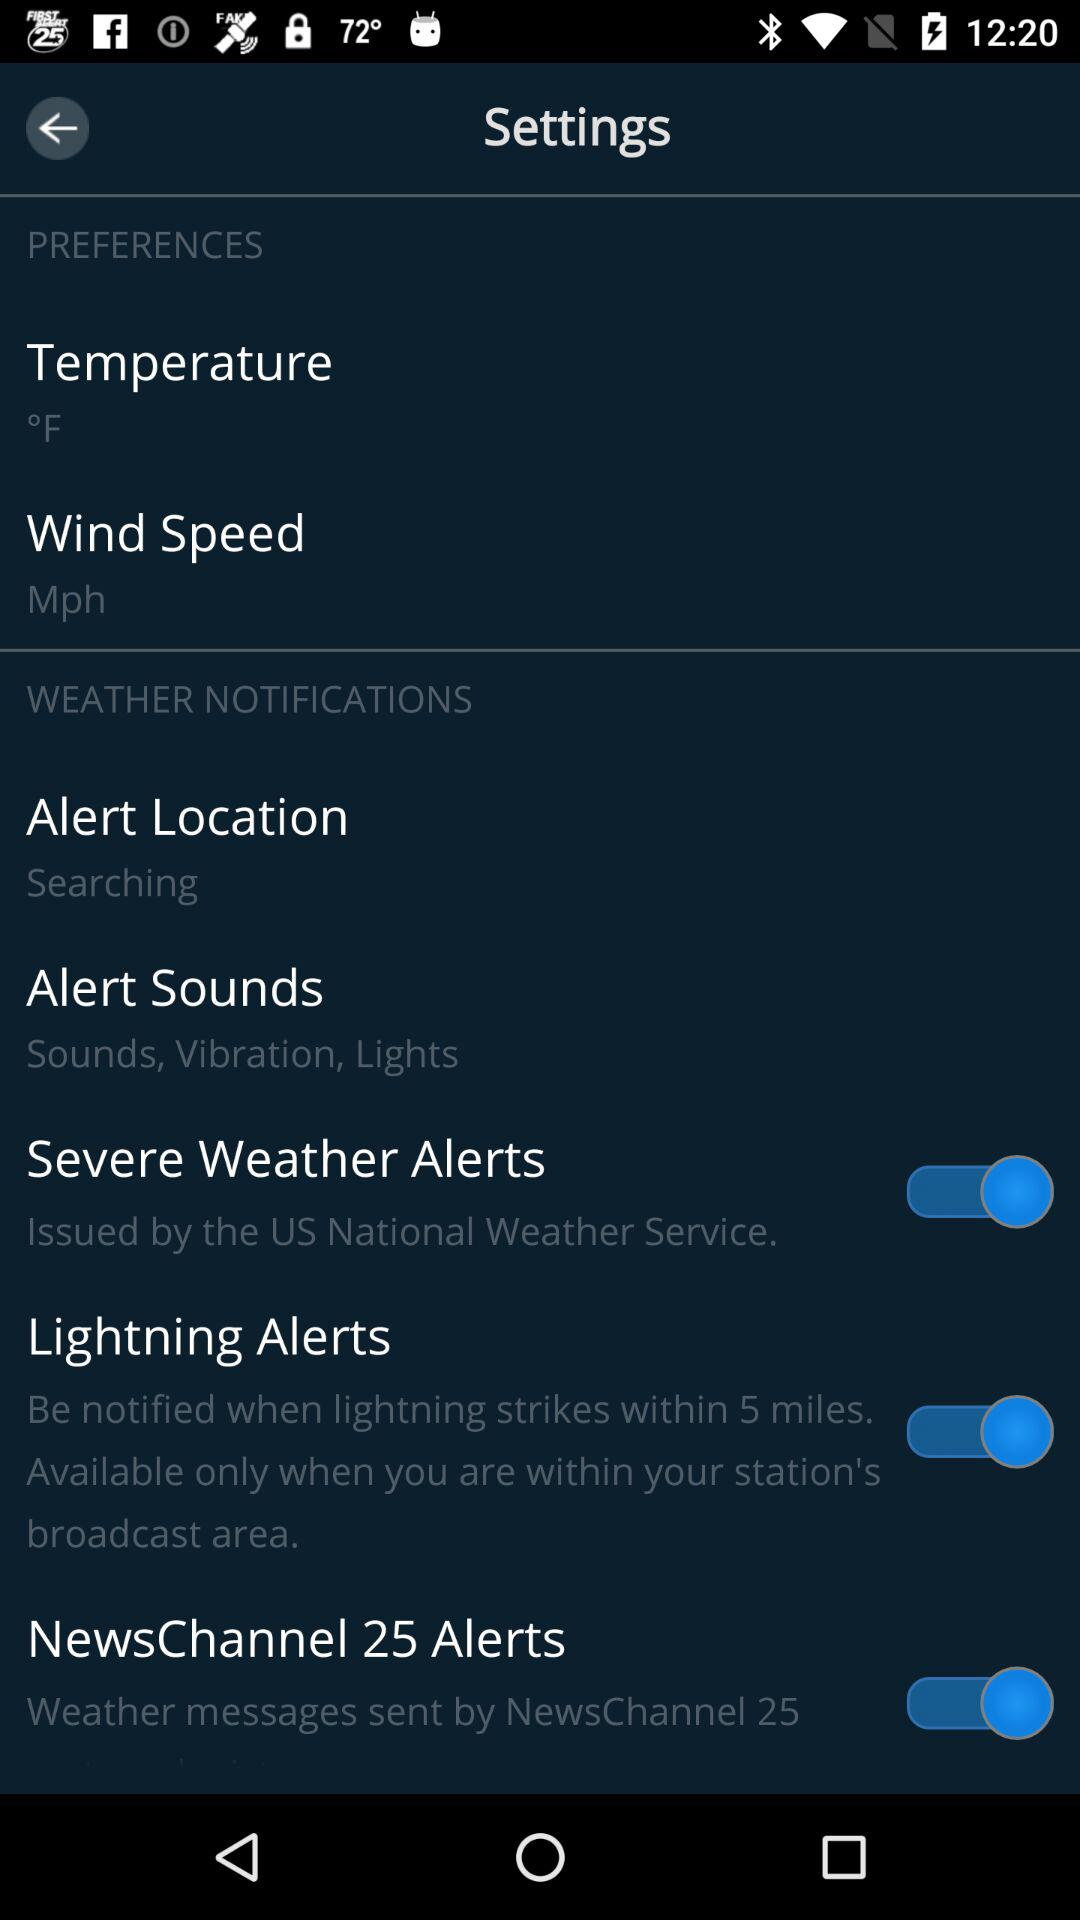What is the status of "Severe Weather Alerts"? The status of "Severe Weather Alerts" is "on". 